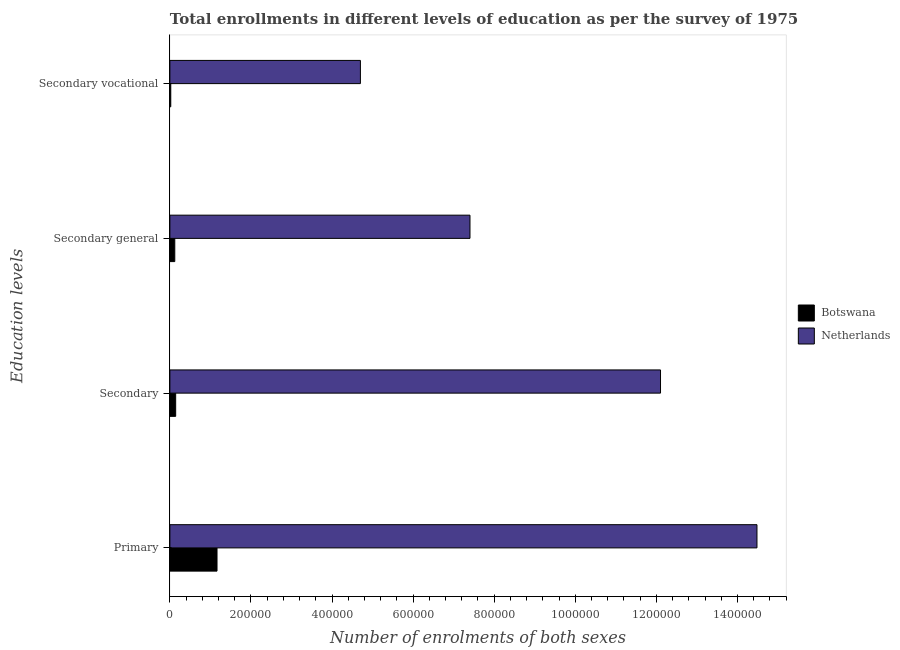Are the number of bars per tick equal to the number of legend labels?
Your answer should be very brief. Yes. How many bars are there on the 4th tick from the top?
Your response must be concise. 2. What is the label of the 4th group of bars from the top?
Make the answer very short. Primary. What is the number of enrolments in secondary vocational education in Botswana?
Your answer should be very brief. 2188. Across all countries, what is the maximum number of enrolments in primary education?
Ensure brevity in your answer.  1.45e+06. Across all countries, what is the minimum number of enrolments in secondary general education?
Offer a terse response. 1.21e+04. In which country was the number of enrolments in secondary general education minimum?
Make the answer very short. Botswana. What is the total number of enrolments in primary education in the graph?
Ensure brevity in your answer.  1.56e+06. What is the difference between the number of enrolments in secondary education in Botswana and that in Netherlands?
Provide a short and direct response. -1.20e+06. What is the difference between the number of enrolments in secondary vocational education in Botswana and the number of enrolments in secondary education in Netherlands?
Offer a terse response. -1.21e+06. What is the average number of enrolments in secondary vocational education per country?
Your answer should be compact. 2.36e+05. What is the difference between the number of enrolments in secondary general education and number of enrolments in secondary vocational education in Netherlands?
Your answer should be compact. 2.70e+05. What is the ratio of the number of enrolments in secondary vocational education in Netherlands to that in Botswana?
Ensure brevity in your answer.  214.8. What is the difference between the highest and the second highest number of enrolments in primary education?
Keep it short and to the point. 1.33e+06. What is the difference between the highest and the lowest number of enrolments in secondary general education?
Ensure brevity in your answer.  7.28e+05. Is it the case that in every country, the sum of the number of enrolments in secondary general education and number of enrolments in primary education is greater than the sum of number of enrolments in secondary education and number of enrolments in secondary vocational education?
Make the answer very short. No. What does the 2nd bar from the top in Primary represents?
Your answer should be compact. Botswana. What does the 2nd bar from the bottom in Secondary represents?
Keep it short and to the point. Netherlands. Is it the case that in every country, the sum of the number of enrolments in primary education and number of enrolments in secondary education is greater than the number of enrolments in secondary general education?
Provide a succinct answer. Yes. How many countries are there in the graph?
Offer a terse response. 2. What is the difference between two consecutive major ticks on the X-axis?
Your answer should be compact. 2.00e+05. How many legend labels are there?
Give a very brief answer. 2. How are the legend labels stacked?
Your response must be concise. Vertical. What is the title of the graph?
Make the answer very short. Total enrollments in different levels of education as per the survey of 1975. What is the label or title of the X-axis?
Your answer should be compact. Number of enrolments of both sexes. What is the label or title of the Y-axis?
Give a very brief answer. Education levels. What is the Number of enrolments of both sexes in Botswana in Primary?
Your answer should be very brief. 1.16e+05. What is the Number of enrolments of both sexes in Netherlands in Primary?
Keep it short and to the point. 1.45e+06. What is the Number of enrolments of both sexes in Botswana in Secondary?
Keep it short and to the point. 1.43e+04. What is the Number of enrolments of both sexes in Netherlands in Secondary?
Your answer should be compact. 1.21e+06. What is the Number of enrolments of both sexes of Botswana in Secondary general?
Give a very brief answer. 1.21e+04. What is the Number of enrolments of both sexes in Netherlands in Secondary general?
Make the answer very short. 7.40e+05. What is the Number of enrolments of both sexes of Botswana in Secondary vocational?
Ensure brevity in your answer.  2188. What is the Number of enrolments of both sexes in Netherlands in Secondary vocational?
Keep it short and to the point. 4.70e+05. Across all Education levels, what is the maximum Number of enrolments of both sexes in Botswana?
Make the answer very short. 1.16e+05. Across all Education levels, what is the maximum Number of enrolments of both sexes in Netherlands?
Your response must be concise. 1.45e+06. Across all Education levels, what is the minimum Number of enrolments of both sexes of Botswana?
Keep it short and to the point. 2188. Across all Education levels, what is the minimum Number of enrolments of both sexes of Netherlands?
Make the answer very short. 4.70e+05. What is the total Number of enrolments of both sexes in Botswana in the graph?
Make the answer very short. 1.45e+05. What is the total Number of enrolments of both sexes of Netherlands in the graph?
Offer a very short reply. 3.87e+06. What is the difference between the Number of enrolments of both sexes of Botswana in Primary and that in Secondary?
Provide a short and direct response. 1.02e+05. What is the difference between the Number of enrolments of both sexes in Netherlands in Primary and that in Secondary?
Offer a very short reply. 2.38e+05. What is the difference between the Number of enrolments of both sexes of Botswana in Primary and that in Secondary general?
Give a very brief answer. 1.04e+05. What is the difference between the Number of enrolments of both sexes in Netherlands in Primary and that in Secondary general?
Your answer should be very brief. 7.08e+05. What is the difference between the Number of enrolments of both sexes of Botswana in Primary and that in Secondary vocational?
Offer a terse response. 1.14e+05. What is the difference between the Number of enrolments of both sexes of Netherlands in Primary and that in Secondary vocational?
Your answer should be very brief. 9.78e+05. What is the difference between the Number of enrolments of both sexes of Botswana in Secondary and that in Secondary general?
Give a very brief answer. 2188. What is the difference between the Number of enrolments of both sexes in Netherlands in Secondary and that in Secondary general?
Offer a very short reply. 4.70e+05. What is the difference between the Number of enrolments of both sexes of Botswana in Secondary and that in Secondary vocational?
Offer a very short reply. 1.21e+04. What is the difference between the Number of enrolments of both sexes in Netherlands in Secondary and that in Secondary vocational?
Provide a short and direct response. 7.40e+05. What is the difference between the Number of enrolments of both sexes in Botswana in Secondary general and that in Secondary vocational?
Your answer should be compact. 9910. What is the difference between the Number of enrolments of both sexes of Netherlands in Secondary general and that in Secondary vocational?
Provide a succinct answer. 2.70e+05. What is the difference between the Number of enrolments of both sexes of Botswana in Primary and the Number of enrolments of both sexes of Netherlands in Secondary?
Your response must be concise. -1.09e+06. What is the difference between the Number of enrolments of both sexes of Botswana in Primary and the Number of enrolments of both sexes of Netherlands in Secondary general?
Your response must be concise. -6.24e+05. What is the difference between the Number of enrolments of both sexes of Botswana in Primary and the Number of enrolments of both sexes of Netherlands in Secondary vocational?
Offer a very short reply. -3.54e+05. What is the difference between the Number of enrolments of both sexes of Botswana in Secondary and the Number of enrolments of both sexes of Netherlands in Secondary general?
Offer a terse response. -7.26e+05. What is the difference between the Number of enrolments of both sexes of Botswana in Secondary and the Number of enrolments of both sexes of Netherlands in Secondary vocational?
Provide a short and direct response. -4.56e+05. What is the difference between the Number of enrolments of both sexes in Botswana in Secondary general and the Number of enrolments of both sexes in Netherlands in Secondary vocational?
Offer a terse response. -4.58e+05. What is the average Number of enrolments of both sexes in Botswana per Education levels?
Keep it short and to the point. 3.62e+04. What is the average Number of enrolments of both sexes of Netherlands per Education levels?
Provide a succinct answer. 9.67e+05. What is the difference between the Number of enrolments of both sexes of Botswana and Number of enrolments of both sexes of Netherlands in Primary?
Ensure brevity in your answer.  -1.33e+06. What is the difference between the Number of enrolments of both sexes of Botswana and Number of enrolments of both sexes of Netherlands in Secondary?
Offer a terse response. -1.20e+06. What is the difference between the Number of enrolments of both sexes in Botswana and Number of enrolments of both sexes in Netherlands in Secondary general?
Provide a short and direct response. -7.28e+05. What is the difference between the Number of enrolments of both sexes in Botswana and Number of enrolments of both sexes in Netherlands in Secondary vocational?
Offer a terse response. -4.68e+05. What is the ratio of the Number of enrolments of both sexes in Botswana in Primary to that in Secondary?
Your answer should be very brief. 8.14. What is the ratio of the Number of enrolments of both sexes of Netherlands in Primary to that in Secondary?
Make the answer very short. 1.2. What is the ratio of the Number of enrolments of both sexes in Botswana in Primary to that in Secondary general?
Keep it short and to the point. 9.61. What is the ratio of the Number of enrolments of both sexes in Netherlands in Primary to that in Secondary general?
Offer a terse response. 1.96. What is the ratio of the Number of enrolments of both sexes of Botswana in Primary to that in Secondary vocational?
Offer a very short reply. 53.15. What is the ratio of the Number of enrolments of both sexes of Netherlands in Primary to that in Secondary vocational?
Make the answer very short. 3.08. What is the ratio of the Number of enrolments of both sexes of Botswana in Secondary to that in Secondary general?
Make the answer very short. 1.18. What is the ratio of the Number of enrolments of both sexes of Netherlands in Secondary to that in Secondary general?
Keep it short and to the point. 1.63. What is the ratio of the Number of enrolments of both sexes of Botswana in Secondary to that in Secondary vocational?
Offer a very short reply. 6.53. What is the ratio of the Number of enrolments of both sexes of Netherlands in Secondary to that in Secondary vocational?
Give a very brief answer. 2.58. What is the ratio of the Number of enrolments of both sexes of Botswana in Secondary general to that in Secondary vocational?
Offer a terse response. 5.53. What is the ratio of the Number of enrolments of both sexes in Netherlands in Secondary general to that in Secondary vocational?
Provide a short and direct response. 1.58. What is the difference between the highest and the second highest Number of enrolments of both sexes of Botswana?
Your answer should be very brief. 1.02e+05. What is the difference between the highest and the second highest Number of enrolments of both sexes of Netherlands?
Provide a short and direct response. 2.38e+05. What is the difference between the highest and the lowest Number of enrolments of both sexes of Botswana?
Your response must be concise. 1.14e+05. What is the difference between the highest and the lowest Number of enrolments of both sexes of Netherlands?
Your answer should be compact. 9.78e+05. 